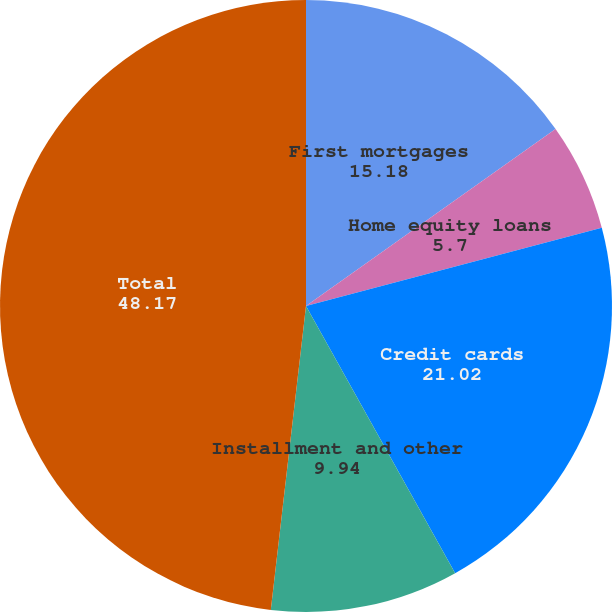Convert chart to OTSL. <chart><loc_0><loc_0><loc_500><loc_500><pie_chart><fcel>First mortgages<fcel>Home equity loans<fcel>Credit cards<fcel>Installment and other<fcel>Total<nl><fcel>15.18%<fcel>5.7%<fcel>21.02%<fcel>9.94%<fcel>48.17%<nl></chart> 